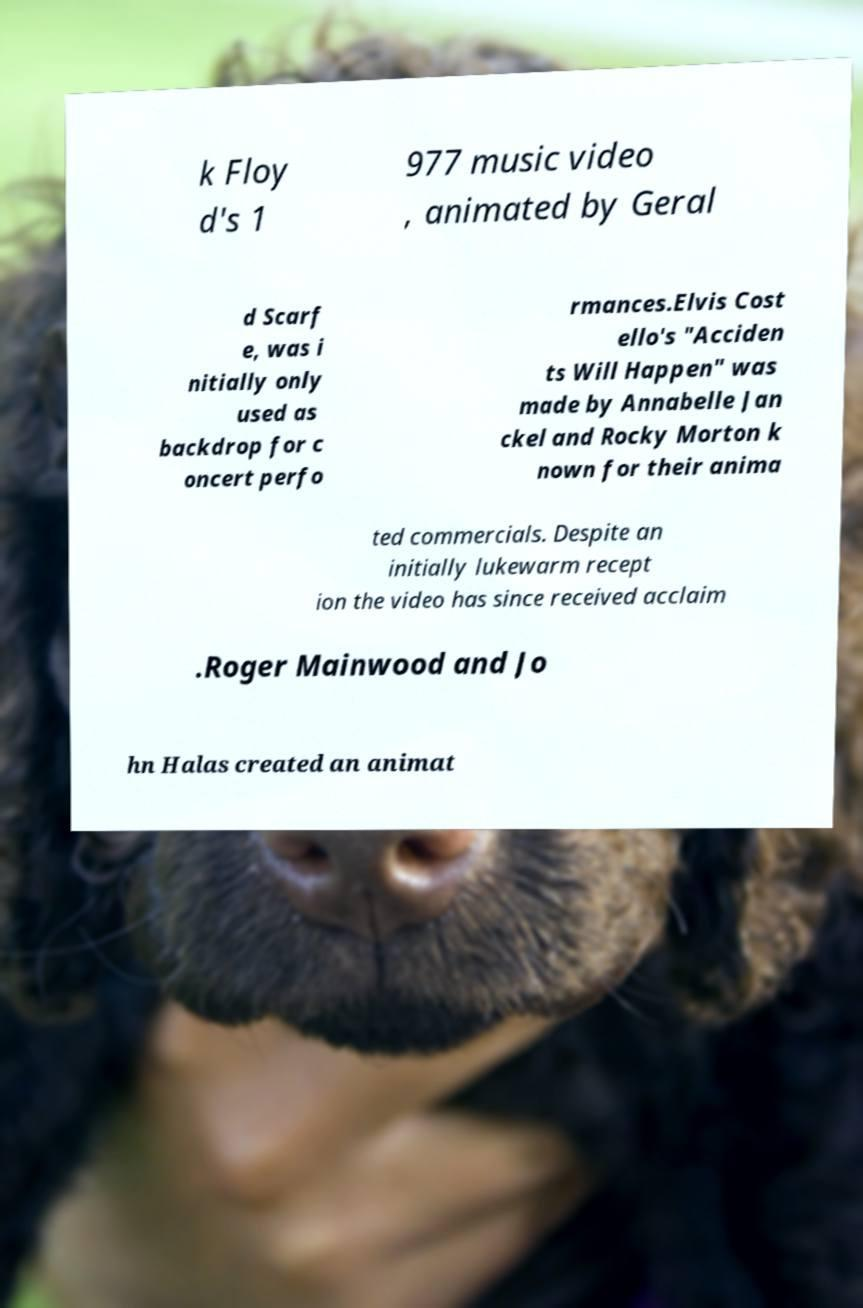Could you assist in decoding the text presented in this image and type it out clearly? k Floy d's 1 977 music video , animated by Geral d Scarf e, was i nitially only used as backdrop for c oncert perfo rmances.Elvis Cost ello's "Acciden ts Will Happen" was made by Annabelle Jan ckel and Rocky Morton k nown for their anima ted commercials. Despite an initially lukewarm recept ion the video has since received acclaim .Roger Mainwood and Jo hn Halas created an animat 